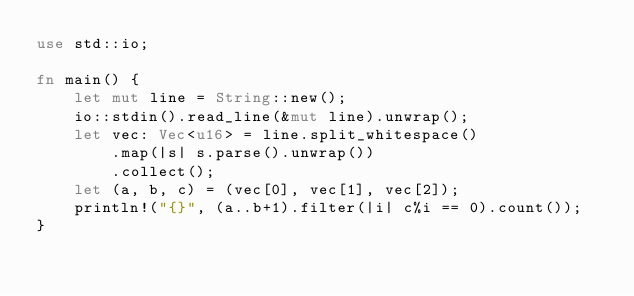Convert code to text. <code><loc_0><loc_0><loc_500><loc_500><_Rust_>use std::io;

fn main() {
    let mut line = String::new();
    io::stdin().read_line(&mut line).unwrap();
    let vec: Vec<u16> = line.split_whitespace()
        .map(|s| s.parse().unwrap())
        .collect();
    let (a, b, c) = (vec[0], vec[1], vec[2]);
    println!("{}", (a..b+1).filter(|i| c%i == 0).count());
}
</code> 